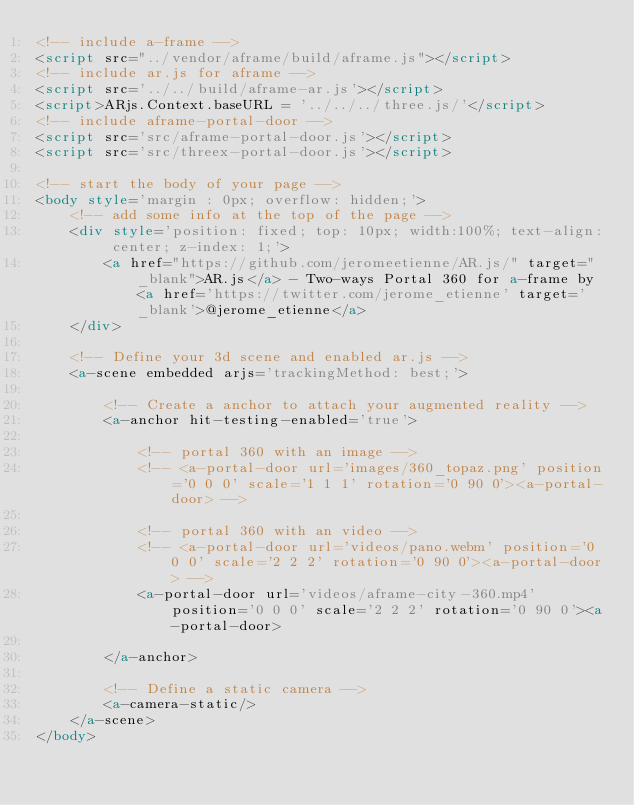Convert code to text. <code><loc_0><loc_0><loc_500><loc_500><_HTML_><!-- include a-frame -->
<script src="../vendor/aframe/build/aframe.js"></script>
<!-- include ar.js for aframe -->
<script src='../../build/aframe-ar.js'></script>
<script>ARjs.Context.baseURL = '../../../three.js/'</script>
<!-- include aframe-portal-door -->
<script src='src/aframe-portal-door.js'></script>
<script src='src/threex-portal-door.js'></script>

<!-- start the body of your page -->
<body style='margin : 0px; overflow: hidden;'>
	<!-- add some info at the top of the page -->
	<div style='position: fixed; top: 10px; width:100%; text-align: center; z-index: 1;'>
		<a href="https://github.com/jeromeetienne/AR.js/" target="_blank">AR.js</a> - Two-ways Portal 360 for a-frame by <a href='https://twitter.com/jerome_etienne' target='_blank'>@jerome_etienne</a>
	</div>

	<!-- Define your 3d scene and enabled ar.js -->
	<a-scene embedded arjs='trackingMethod: best;'>

		<!-- Create a anchor to attach your augmented reality -->
		<a-anchor hit-testing-enabled='true'>

			<!-- portal 360 with an image -->
			<!-- <a-portal-door url='images/360_topaz.png' position='0 0 0' scale='1 1 1' rotation='0 90 0'><a-portal-door> -->

			<!-- portal 360 with an video -->
			<!-- <a-portal-door url='videos/pano.webm' position='0 0 0' scale='2 2 2' rotation='0 90 0'><a-portal-door> -->
			<a-portal-door url='videos/aframe-city-360.mp4' position='0 0 0' scale='2 2 2' rotation='0 90 0'><a-portal-door>

		</a-anchor>

		<!-- Define a static camera -->
		<a-camera-static/>
	</a-scene>
</body>
</code> 